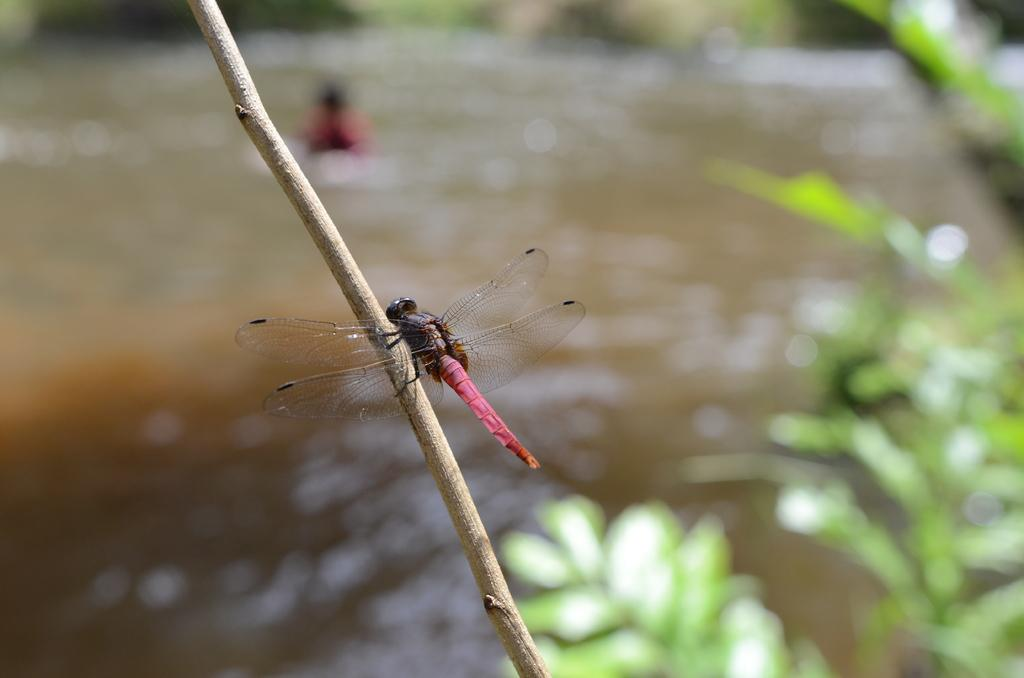What insect can be seen in the image? There is a dragonfly in the image. What object is present in the image alongside the dragonfly? There is a stick in the image. What type of vegetation is visible on the right side of the image? There are leaves on the right side of the image. How would you describe the background of the image? The background of the image is blurry. What type of punishment is being administered to the dragonfly in the image? There is no punishment being administered to the dragonfly in the image; it is simply resting on a stick. Is there a veil present in the image? No, there is no veil present in the image. 